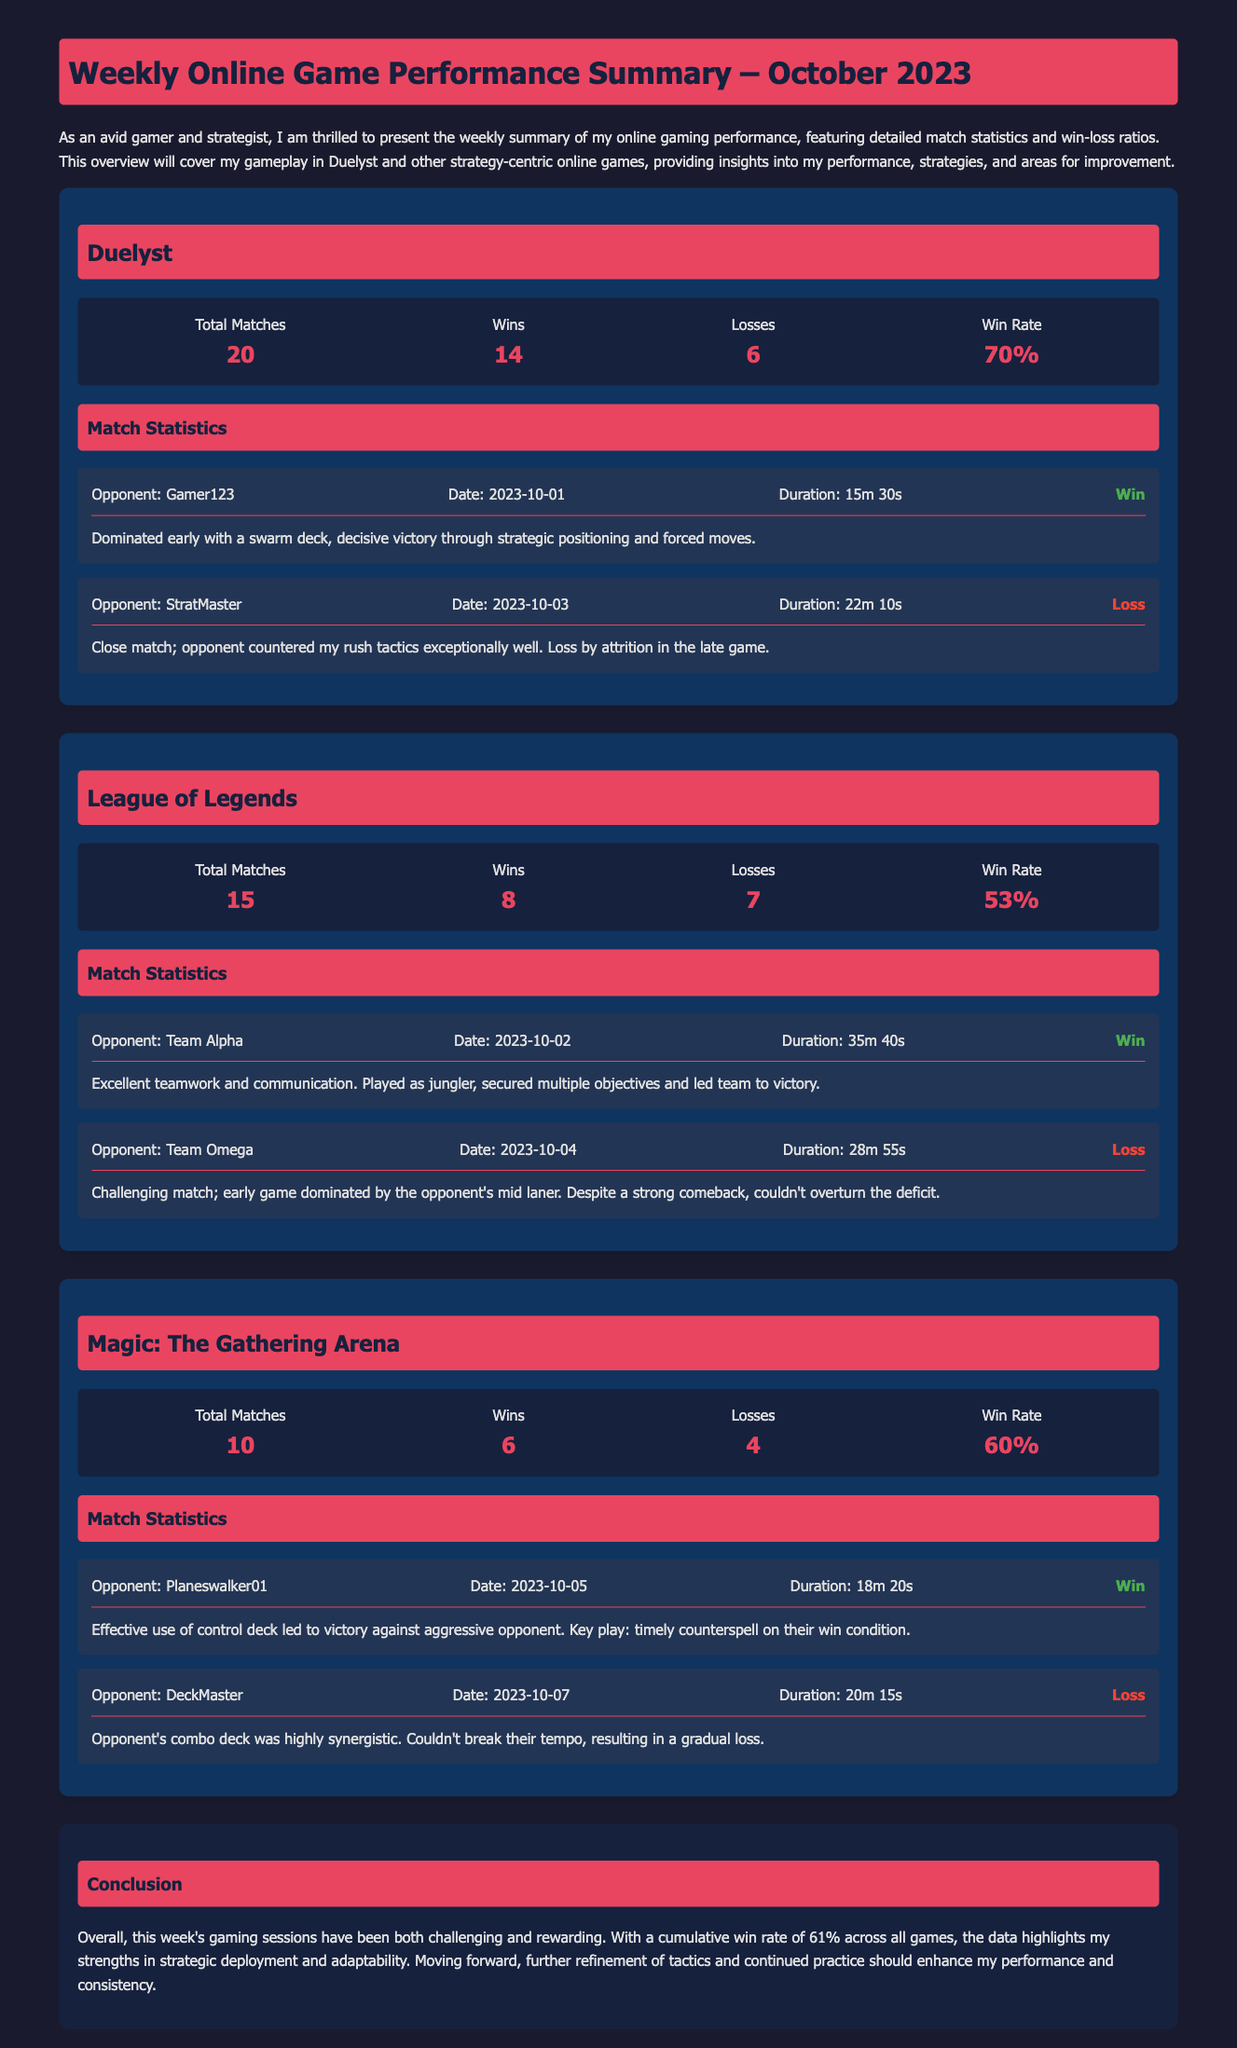What is the total number of matches played in Duelyst? The total number of matches played in Duelyst is listed in the metrics section of the document.
Answer: 20 What was the win rate for League of Legends? The win rate for League of Legends is reported in the metrics section.
Answer: 53% Who was the opponent in the match on 2023-10-03? The opponent's name is mentioned in the statistics for the match on that date.
Answer: StratMaster How many losses did Magic: The Gathering Arena have? The number of losses for Magic: The Gathering Arena is specified in the metrics section.
Answer: 4 What strategy led to success against Planeswalker01? The strategy used in the match against Planeswalker01 is detailed in the match statistics.
Answer: Control deck What is the cumulative win rate across all games? The cumulative win rate is given in the conclusion of the document.
Answer: 61% How long did the match against Team Alpha last? The duration of the match is provided in the match statistics for that opponent.
Answer: 35m 40s What was the result of the match against DeckMaster? The result of the match against DeckMaster is identified in the match statistics section.
Answer: Loss 